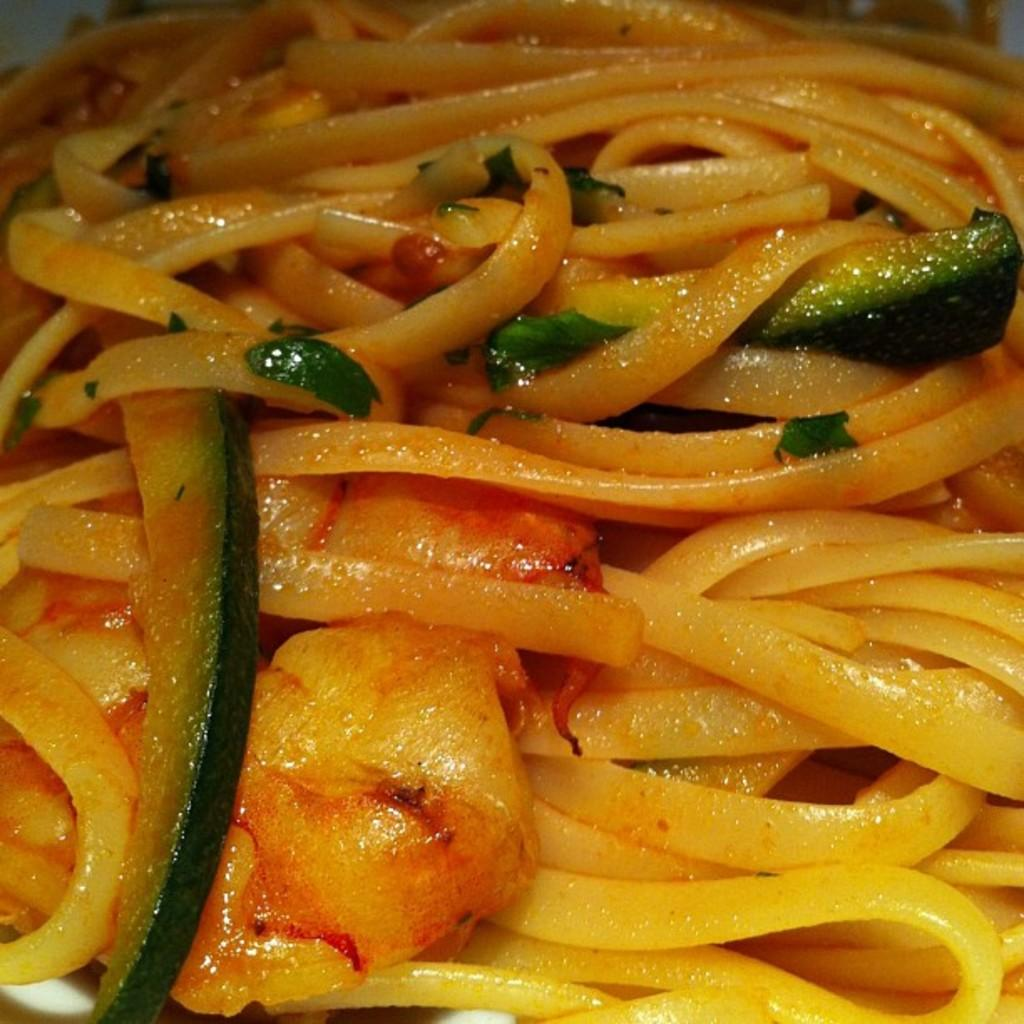What type of food is visible in the image? The image contains food, but the specific type cannot be determined from the provided facts. Can you describe the white-colored object at the bottom of the image? There is a white-colored object at the bottom of the image, but its identity or purpose cannot be determined from the provided facts. What type of meat is being prepared by the writer in the image? There is no meat or writer present in the image, so it is not possible to answer that question. 